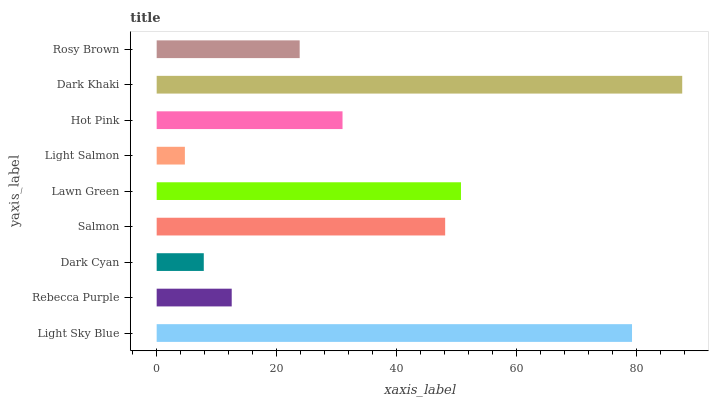Is Light Salmon the minimum?
Answer yes or no. Yes. Is Dark Khaki the maximum?
Answer yes or no. Yes. Is Rebecca Purple the minimum?
Answer yes or no. No. Is Rebecca Purple the maximum?
Answer yes or no. No. Is Light Sky Blue greater than Rebecca Purple?
Answer yes or no. Yes. Is Rebecca Purple less than Light Sky Blue?
Answer yes or no. Yes. Is Rebecca Purple greater than Light Sky Blue?
Answer yes or no. No. Is Light Sky Blue less than Rebecca Purple?
Answer yes or no. No. Is Hot Pink the high median?
Answer yes or no. Yes. Is Hot Pink the low median?
Answer yes or no. Yes. Is Dark Cyan the high median?
Answer yes or no. No. Is Rosy Brown the low median?
Answer yes or no. No. 